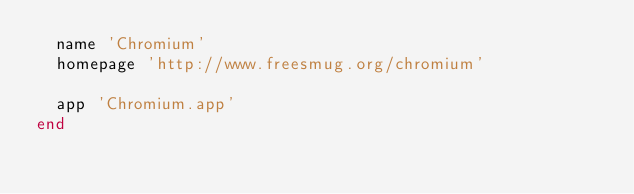Convert code to text. <code><loc_0><loc_0><loc_500><loc_500><_Ruby_>  name 'Chromium'
  homepage 'http://www.freesmug.org/chromium'

  app 'Chromium.app'
end
</code> 